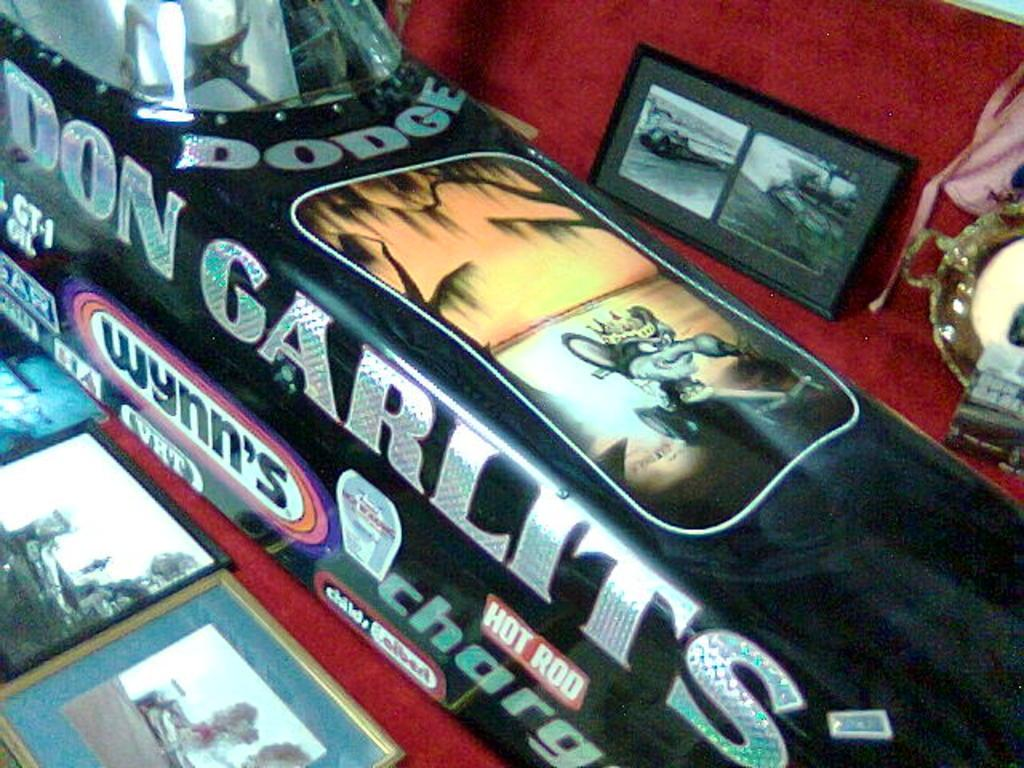What type of objects can be seen in the image? There are photo frames in the image. What is the color of one of the objects in the image? There is a black color object in the image. On what surface are the objects placed in the image? There are objects on a red color surface in the image. How many beginner birds are sitting on the brothers' shoulders in the image? There are no birds or brothers present in the image, so this question cannot be answered. 